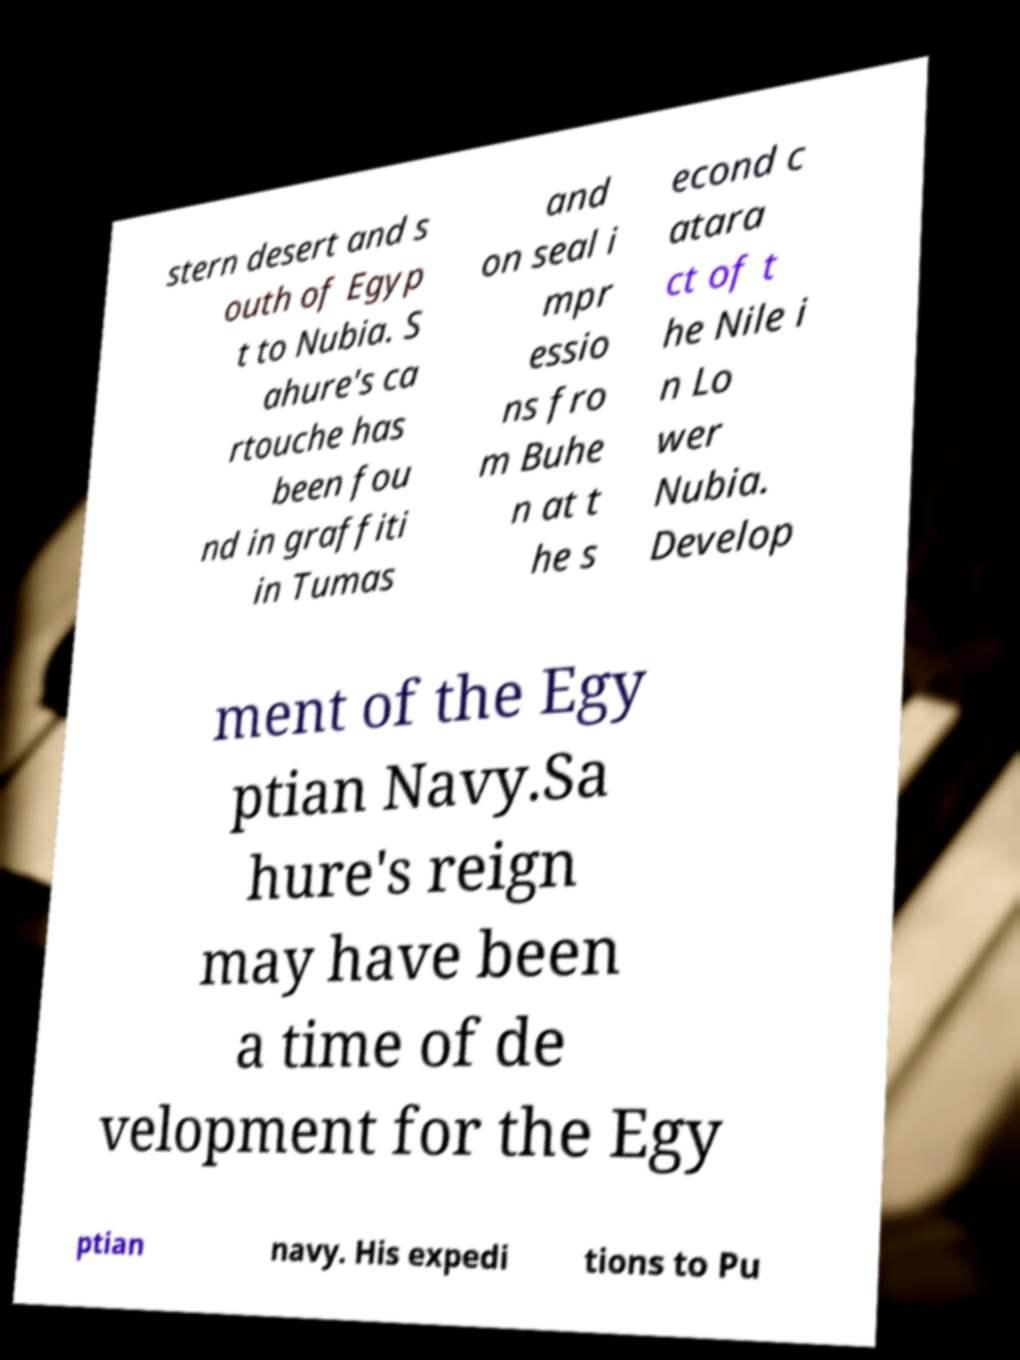Please read and relay the text visible in this image. What does it say? stern desert and s outh of Egyp t to Nubia. S ahure's ca rtouche has been fou nd in graffiti in Tumas and on seal i mpr essio ns fro m Buhe n at t he s econd c atara ct of t he Nile i n Lo wer Nubia. Develop ment of the Egy ptian Navy.Sa hure's reign may have been a time of de velopment for the Egy ptian navy. His expedi tions to Pu 